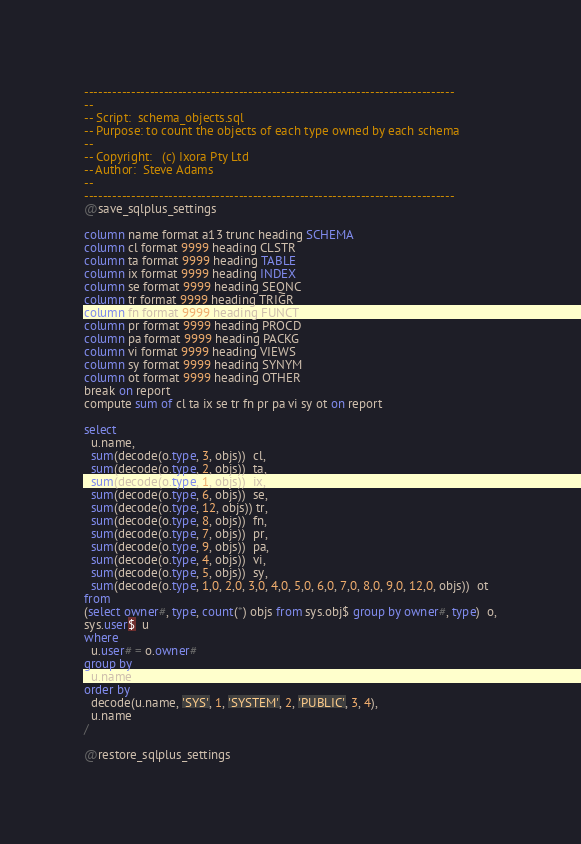<code> <loc_0><loc_0><loc_500><loc_500><_SQL_>-------------------------------------------------------------------------------
--
-- Script:	schema_objects.sql
-- Purpose:	to count the objects of each type owned by each schema
--
-- Copyright:	(c) Ixora Pty Ltd
-- Author:	Steve Adams
--
-------------------------------------------------------------------------------
@save_sqlplus_settings

column name format a13 trunc heading SCHEMA
column cl format 9999 heading CLSTR
column ta format 9999 heading TABLE
column ix format 9999 heading INDEX
column se format 9999 heading SEQNC
column tr format 9999 heading TRIGR
column fn format 9999 heading FUNCT
column pr format 9999 heading PROCD
column pa format 9999 heading PACKG
column vi format 9999 heading VIEWS
column sy format 9999 heading SYNYM
column ot format 9999 heading OTHER
break on report
compute sum of cl ta ix se tr fn pr pa vi sy ot on report

select
  u.name,
  sum(decode(o.type, 3, objs))  cl,
  sum(decode(o.type, 2, objs))  ta,
  sum(decode(o.type, 1, objs))  ix,
  sum(decode(o.type, 6, objs))  se,
  sum(decode(o.type, 12, objs)) tr,
  sum(decode(o.type, 8, objs))  fn,
  sum(decode(o.type, 7, objs))  pr,
  sum(decode(o.type, 9, objs))  pa,
  sum(decode(o.type, 4, objs))  vi,
  sum(decode(o.type, 5, objs))  sy,
  sum(decode(o.type, 1,0, 2,0, 3,0, 4,0, 5,0, 6,0, 7,0, 8,0, 9,0, 12,0, objs))  ot
from
(select owner#, type, count(*) objs from sys.obj$ group by owner#, type)  o,
sys.user$  u
where
  u.user# = o.owner#
group by
  u.name
order by
  decode(u.name, 'SYS', 1, 'SYSTEM', 2, 'PUBLIC', 3, 4),
  u.name
/

@restore_sqlplus_settings
</code> 